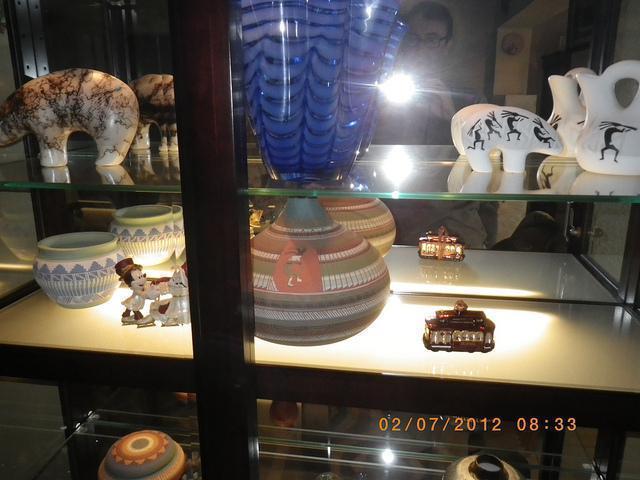What is the mouse's wife's name?
Indicate the correct response by choosing from the four available options to answer the question.
Options: Justina, minnie, dasha, delores. Minnie. 